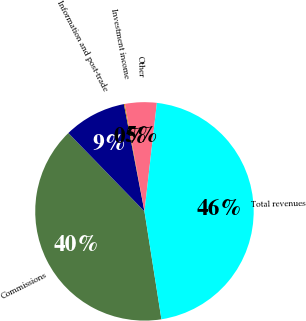<chart> <loc_0><loc_0><loc_500><loc_500><pie_chart><fcel>Commissions<fcel>Information and post-trade<fcel>Investment income<fcel>Other<fcel>Total revenues<nl><fcel>40.22%<fcel>9.25%<fcel>0.14%<fcel>4.69%<fcel>45.7%<nl></chart> 